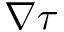<formula> <loc_0><loc_0><loc_500><loc_500>\nabla \tau</formula> 